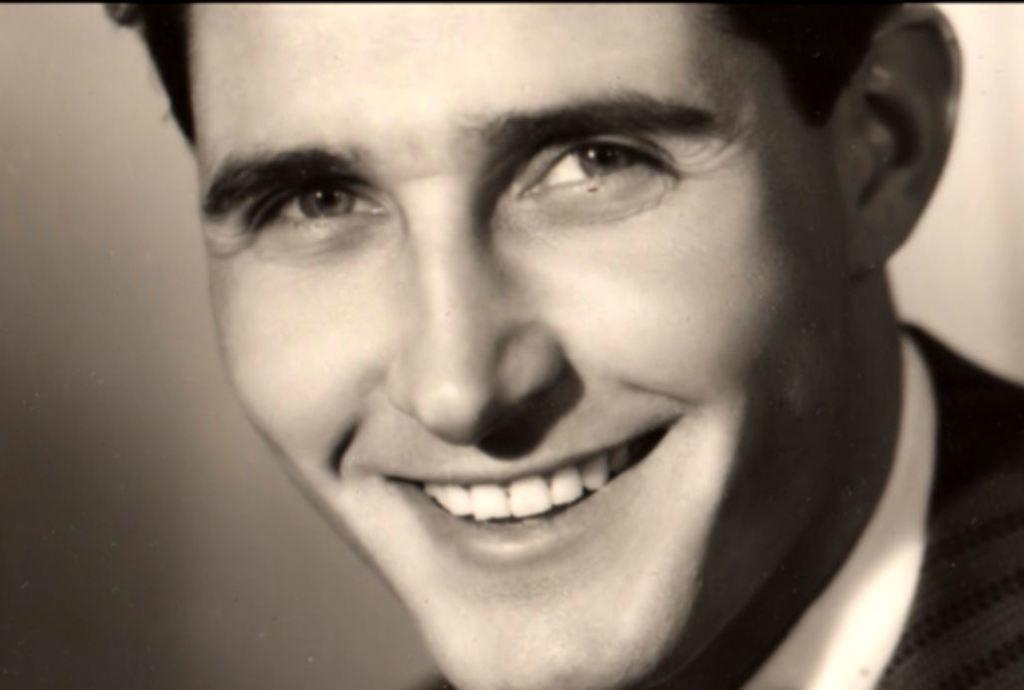What is the main subject of the image? There is a person in the image. What color scheme is used in the image? The image is in black and white. What type of thing can be seen looking at the person in the image? There is no specific thing looking at the person in the image, as it is a black and white photograph. What is the level of friction between the person and the ground in the image? The level of friction between the person and the ground cannot be determined from the image, as it is a black and white photograph. 